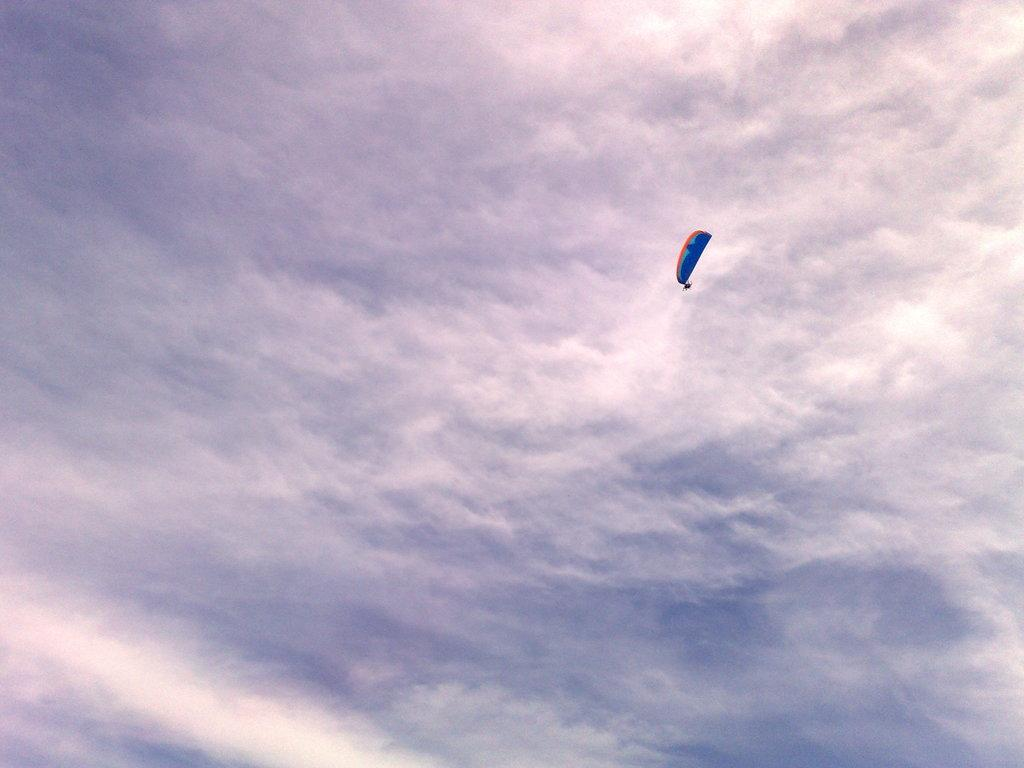What can be seen in the background of the image? There is sky in the image. What is present in the sky in the image? There are clouds in the image. What is the main object in the image? There is a parachute in the image. What is the argument between the two women in the image? There are no women or argument present in the image; it features sky, clouds, and a parachute. 